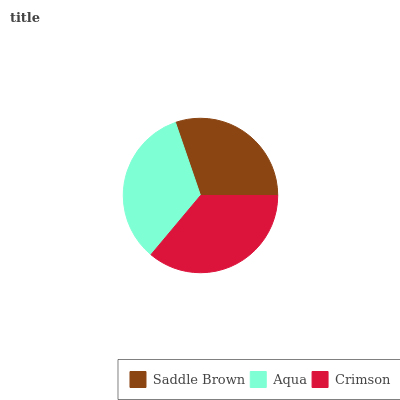Is Saddle Brown the minimum?
Answer yes or no. Yes. Is Crimson the maximum?
Answer yes or no. Yes. Is Aqua the minimum?
Answer yes or no. No. Is Aqua the maximum?
Answer yes or no. No. Is Aqua greater than Saddle Brown?
Answer yes or no. Yes. Is Saddle Brown less than Aqua?
Answer yes or no. Yes. Is Saddle Brown greater than Aqua?
Answer yes or no. No. Is Aqua less than Saddle Brown?
Answer yes or no. No. Is Aqua the high median?
Answer yes or no. Yes. Is Aqua the low median?
Answer yes or no. Yes. Is Crimson the high median?
Answer yes or no. No. Is Saddle Brown the low median?
Answer yes or no. No. 